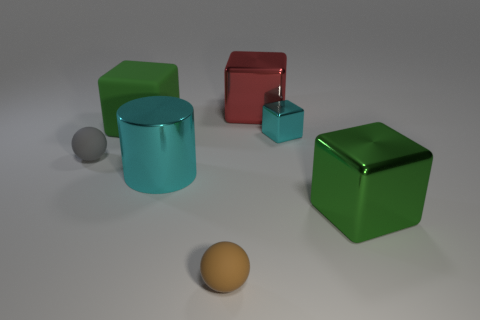Subtract all tiny cyan blocks. How many blocks are left? 3 Subtract all brown balls. How many balls are left? 1 Add 2 cyan metallic cylinders. How many objects exist? 9 Subtract all cylinders. How many objects are left? 6 Add 6 big green shiny things. How many big green shiny things are left? 7 Add 6 small blue metallic objects. How many small blue metallic objects exist? 6 Subtract 0 gray cylinders. How many objects are left? 7 Subtract 1 balls. How many balls are left? 1 Subtract all cyan balls. Subtract all red cubes. How many balls are left? 2 Subtract all green spheres. How many gray blocks are left? 0 